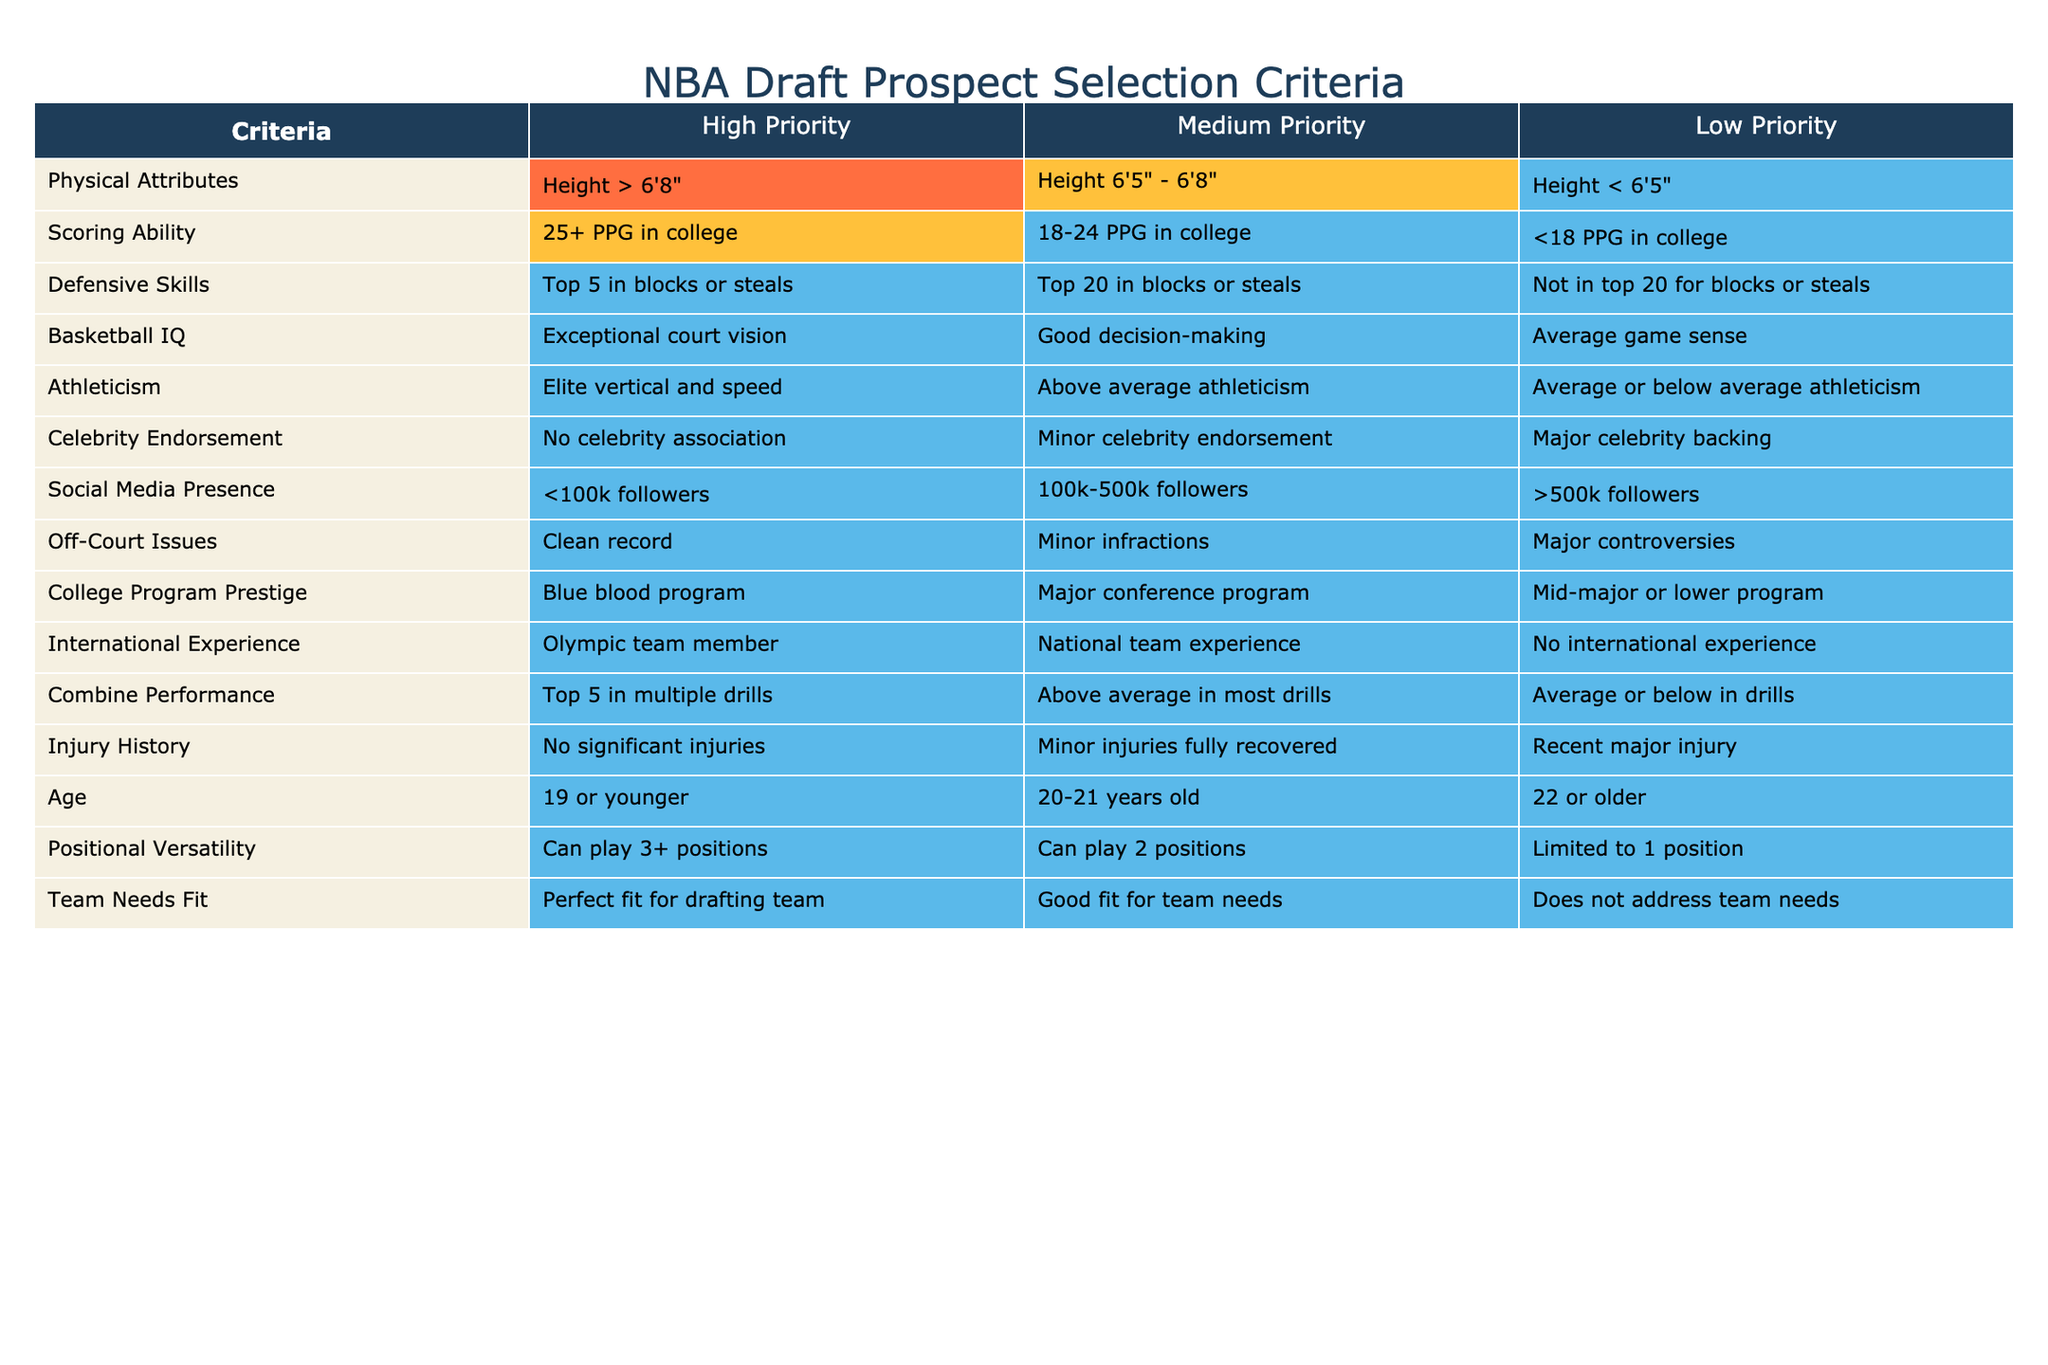What is the high priority criterion for physical attributes? According to the table, the high priority criterion for physical attributes is "Height > 6'8"".
Answer: Height > 6'8" Which criteria fall under low priority for scoring ability? The table indicates that the low priority criterion for scoring ability is "<18 PPG in college".
Answer: <18 PPG in college Is there a high priority attached to off-court issues? Yes, the high priority for off-court issues is "Clean record", as indicated in the table.
Answer: Yes How many criteria have a medium priority in the injury history category? There is one medium priority criterion for injury history, which is "Minor injuries fully recovered".
Answer: 1 If a prospect has "Top 5 in blocks or steals", what priority is it categorized under for defensive skills? The table shows that "Top 5 in blocks or steals" is categorized as high priority for defensive skills.
Answer: High Priority What is the average level of social media presence for medium priority? For medium priority in social media presence, the criterion is "100k-500k followers". The table only lists one value, so the average is that value itself, 100k-500k followers.
Answer: 100k-500k followers Does having no significant injuries earn a high priority in the injury history category? Yes, having "No significant injuries" is categorized as high priority in the injury history section.
Answer: Yes What is the difference between high and medium priority criteria for age? The high priority for age is "19 or younger" and the medium priority is "20-21 years old". Thus, the difference in this context refers to the age range, which is 1 to 2 years difference.
Answer: 1 to 2 years How many high priority criteria are there for combine performance and how do they compare to low priority criteria? There is one high priority criterion for combine performance: "Top 5 in multiple drills". There is one low priority criterion: "Average or below in drills". Thus, the priority counts are one for high and one for low, making them equal.
Answer: 1 high, 1 low 